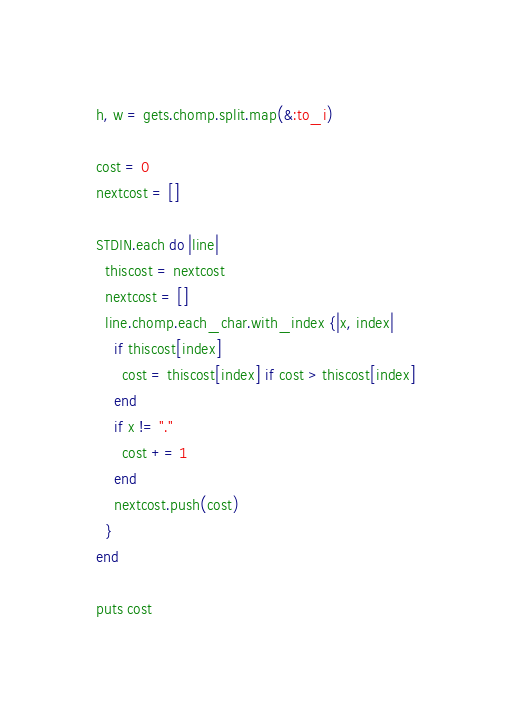Convert code to text. <code><loc_0><loc_0><loc_500><loc_500><_Ruby_>h, w = gets.chomp.split.map(&:to_i)

cost = 0
nextcost = []

STDIN.each do |line|
  thiscost = nextcost
  nextcost = []
  line.chomp.each_char.with_index {|x, index|
    if thiscost[index]
      cost = thiscost[index] if cost > thiscost[index]
    end
    if x != "."
      cost += 1
    end
    nextcost.push(cost)
  }
end

puts cost</code> 